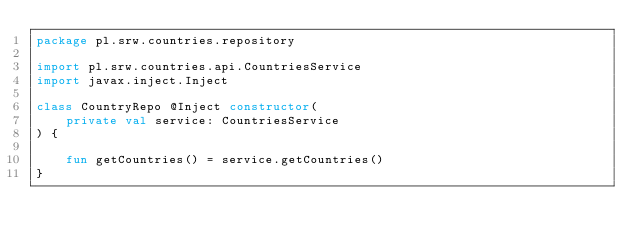Convert code to text. <code><loc_0><loc_0><loc_500><loc_500><_Kotlin_>package pl.srw.countries.repository

import pl.srw.countries.api.CountriesService
import javax.inject.Inject

class CountryRepo @Inject constructor(
    private val service: CountriesService
) {

    fun getCountries() = service.getCountries()
}</code> 